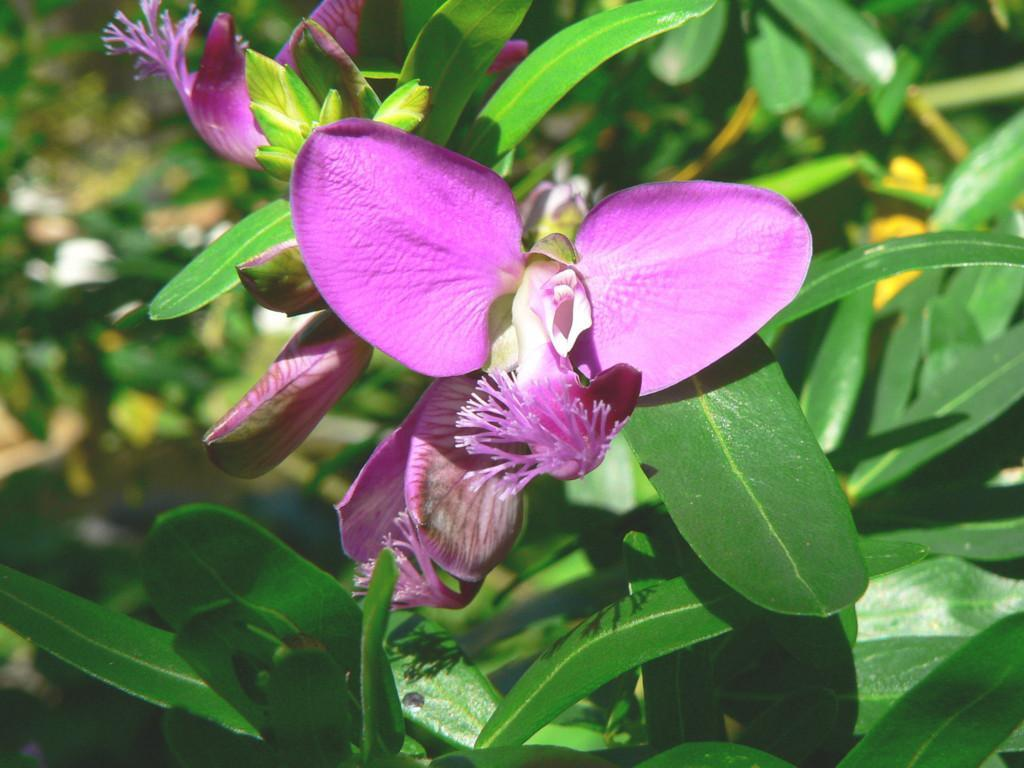What is present in the picture? There is a plant in the picture. What features does the plant have? The plant has leaves and flowers. What can be seen in the background of the picture? There is greenery in the background of the picture. What type of magic is being performed by the plant in the picture? There is no magic being performed by the plant in the picture; it is a regular plant with leaves and flowers. 